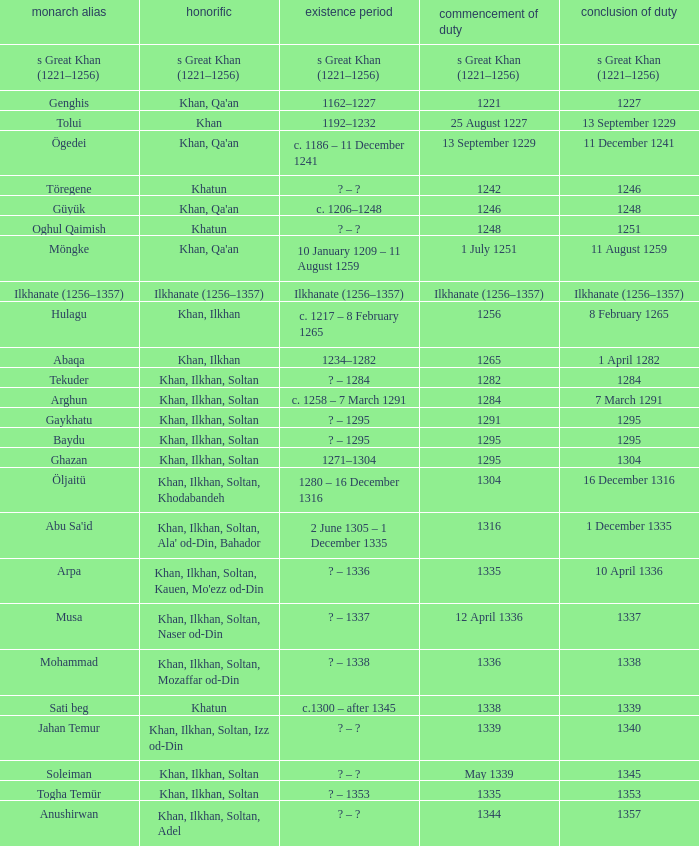What is the entered office that has 1337 as the left office? 12 April 1336. Could you parse the entire table as a dict? {'header': ['monarch alias', 'honorific', 'existence period', 'commencement of duty', 'conclusion of duty'], 'rows': [['s Great Khan (1221–1256)', 's Great Khan (1221–1256)', 's Great Khan (1221–1256)', 's Great Khan (1221–1256)', 's Great Khan (1221–1256)'], ['Genghis', "Khan, Qa'an", '1162–1227', '1221', '1227'], ['Tolui', 'Khan', '1192–1232', '25 August 1227', '13 September 1229'], ['Ögedei', "Khan, Qa'an", 'c. 1186 – 11 December 1241', '13 September 1229', '11 December 1241'], ['Töregene', 'Khatun', '? – ?', '1242', '1246'], ['Güyük', "Khan, Qa'an", 'c. 1206–1248', '1246', '1248'], ['Oghul Qaimish', 'Khatun', '? – ?', '1248', '1251'], ['Möngke', "Khan, Qa'an", '10 January 1209 – 11 August 1259', '1 July 1251', '11 August 1259'], ['Ilkhanate (1256–1357)', 'Ilkhanate (1256–1357)', 'Ilkhanate (1256–1357)', 'Ilkhanate (1256–1357)', 'Ilkhanate (1256–1357)'], ['Hulagu', 'Khan, Ilkhan', 'c. 1217 – 8 February 1265', '1256', '8 February 1265'], ['Abaqa', 'Khan, Ilkhan', '1234–1282', '1265', '1 April 1282'], ['Tekuder', 'Khan, Ilkhan, Soltan', '? – 1284', '1282', '1284'], ['Arghun', 'Khan, Ilkhan, Soltan', 'c. 1258 – 7 March 1291', '1284', '7 March 1291'], ['Gaykhatu', 'Khan, Ilkhan, Soltan', '? – 1295', '1291', '1295'], ['Baydu', 'Khan, Ilkhan, Soltan', '? – 1295', '1295', '1295'], ['Ghazan', 'Khan, Ilkhan, Soltan', '1271–1304', '1295', '1304'], ['Öljaitü', 'Khan, Ilkhan, Soltan, Khodabandeh', '1280 – 16 December 1316', '1304', '16 December 1316'], ["Abu Sa'id", "Khan, Ilkhan, Soltan, Ala' od-Din, Bahador", '2 June 1305 – 1 December 1335', '1316', '1 December 1335'], ['Arpa', "Khan, Ilkhan, Soltan, Kauen, Mo'ezz od-Din", '? – 1336', '1335', '10 April 1336'], ['Musa', 'Khan, Ilkhan, Soltan, Naser od-Din', '? – 1337', '12 April 1336', '1337'], ['Mohammad', 'Khan, Ilkhan, Soltan, Mozaffar od-Din', '? – 1338', '1336', '1338'], ['Sati beg', 'Khatun', 'c.1300 – after 1345', '1338', '1339'], ['Jahan Temur', 'Khan, Ilkhan, Soltan, Izz od-Din', '? – ?', '1339', '1340'], ['Soleiman', 'Khan, Ilkhan, Soltan', '? – ?', 'May 1339', '1345'], ['Togha Temür', 'Khan, Ilkhan, Soltan', '? – 1353', '1335', '1353'], ['Anushirwan', 'Khan, Ilkhan, Soltan, Adel', '? – ?', '1344', '1357']]} 